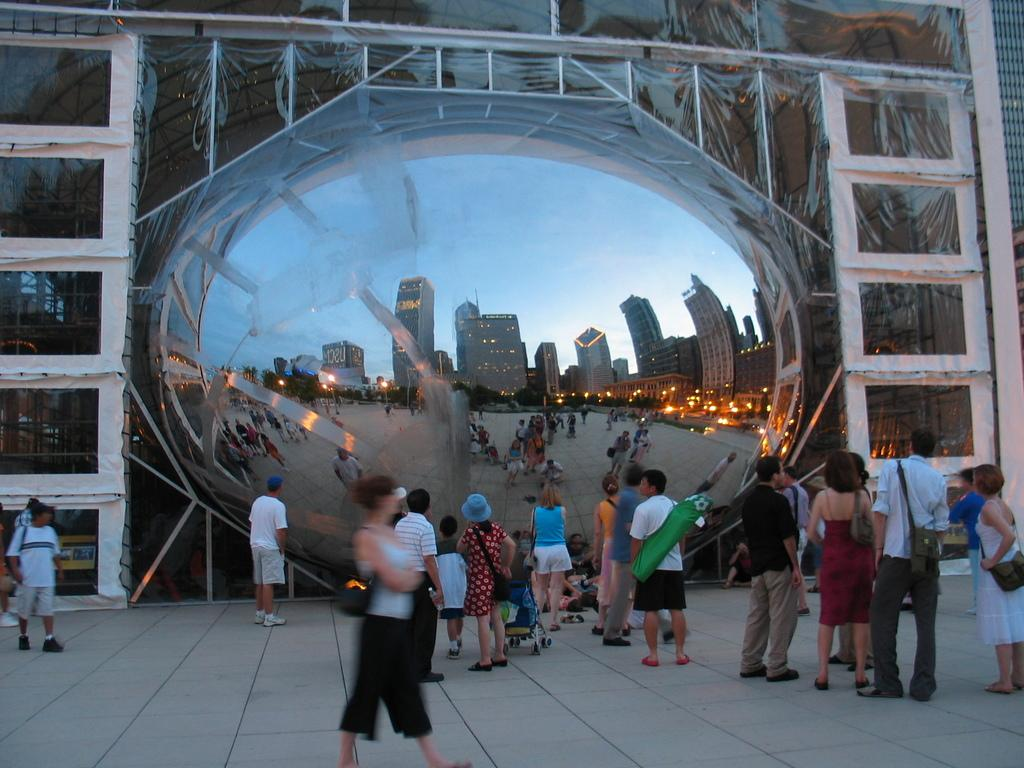What is happening in the image involving a group of people? There is a group of people in the image, with some standing and others walking. What are some people in the group carrying? Some people in the group are carrying bags. What can be seen in the background of the image? There are buildings and lights visible in the background of the image. What type of wood is being used to create pleasure in the image? There is no wood or pleasure-related activity present in the image. 